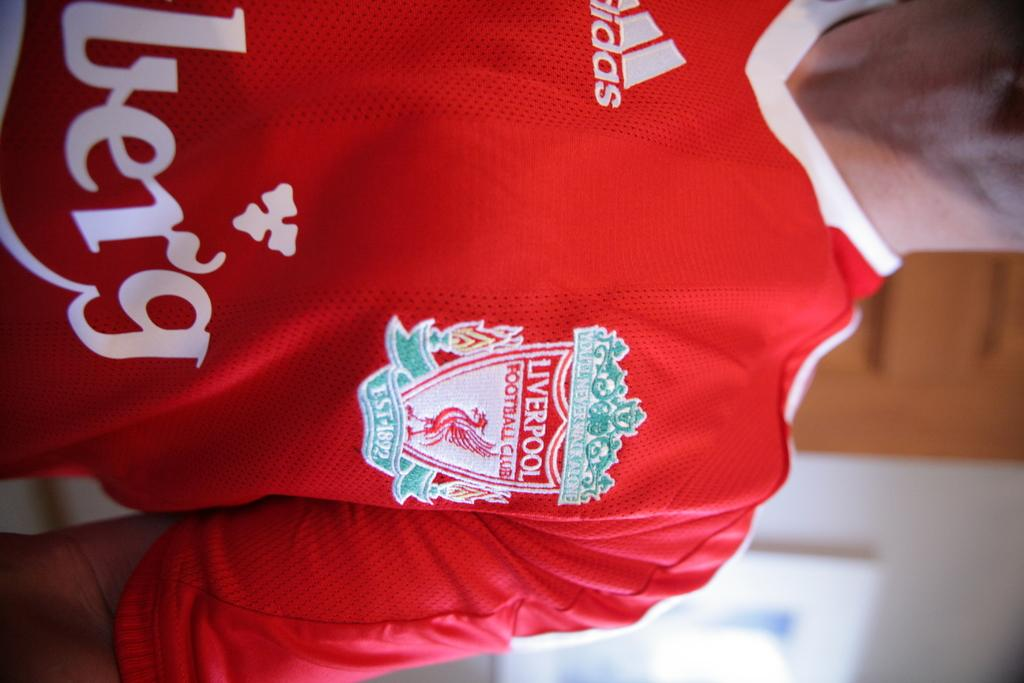<image>
Create a compact narrative representing the image presented. The person shown must be a liverpool fc supporter. 